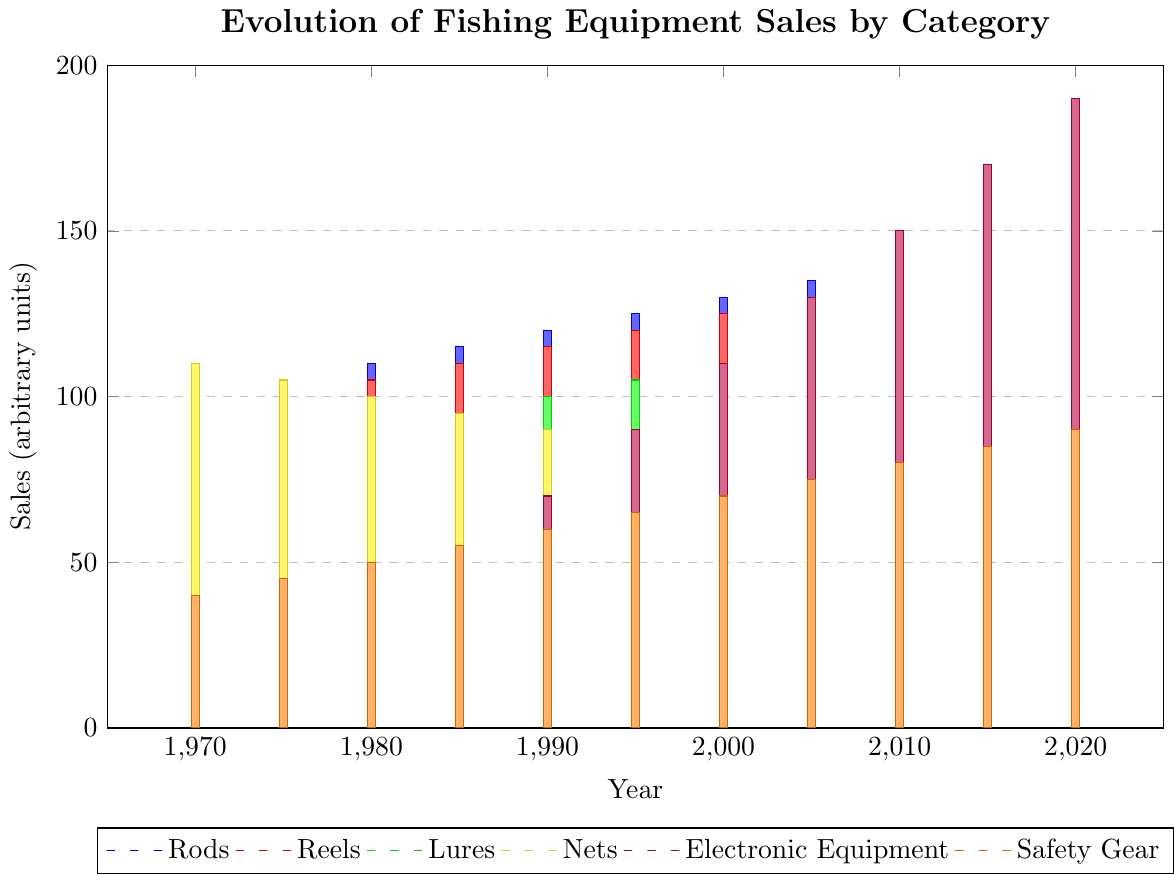What year saw the highest sales for Electronic Equipment? To find the year with the highest sales for Electronic Equipment, locate the highest point of the purple bars in the graph and note the corresponding year on the x-axis. In this case, the year corresponding to the highest bar (190 units) for Electronic Equipment is 2020.
Answer: 2020 Which category had higher sales in 1990: Reels or Nets? Compare the heights of the red and yellow bars for the year 1990. The red bar (Reels) is at 115 units, while the yellow bar (Nets) is at 90 units.
Answer: Reels What is the total sales of Lures from 1970 to 2020? Sum the heights of the green bars for each year from 1970 to 2020: 80 + 85 + 90 + 95 + 100 + 105 + 110 + 115 + 120 + 125 + 130. Adding these values equals 1155 units.
Answer: 1155 How did the sales of Safety Gear change from 1970 to 2020? Look at the heights of the orange bars at the years 1970 and 2020. In 1970, the height is 40 units, and in 2020, it is 90 units. The difference is 90 - 40 = 50 units increase.
Answer: Increased by 50 units Which category had a decline in sales over the years? By scanning the graph, notice that the yellow bar (Nets) shows a decreasing trend from 110 units in 1970 to 60 units in 2020.
Answer: Nets Arrange the categories in descending order of their sales in 2010. In 2010, the bar heights are: Electronic Equipment (150), Reels (135), Rods (140), Lures (120), Safety Gear (80), Nets (70). Ordering these from highest to lowest, we get: Electronic Equipment, Rods, Reels, Lures, Safety Gear, Nets.
Answer: Electronic Equipment, Rods, Reels, Lures, Safety Gear, Nets What is the average sales amount of Rods between 1970 and 2020? To find the average: sum the sales of Rods over all years and divide by the number of years. The sum is 100 + 105 + 110 + 115 + 120 + 125 + 130 + 135 + 140 + 145 + 150 = 1375 units. There are 11 years, so the average is 1375/11 ≈ 125 units.
Answer: 125 units How many more units of Electronic Equipment were sold in 2020 compared to 2000? Subtract the number of units in 2000 from the number in 2020: 190 - 110 = 80 units.
Answer: 80 units What is the sales trend of Nets from 1970 to 2020? Observe the yellow bars from 1970 to 2020; they decrease consistently over the years, showing a downward trend from 110 units in 1970 to 60 units in 2020.
Answer: Downward trend 